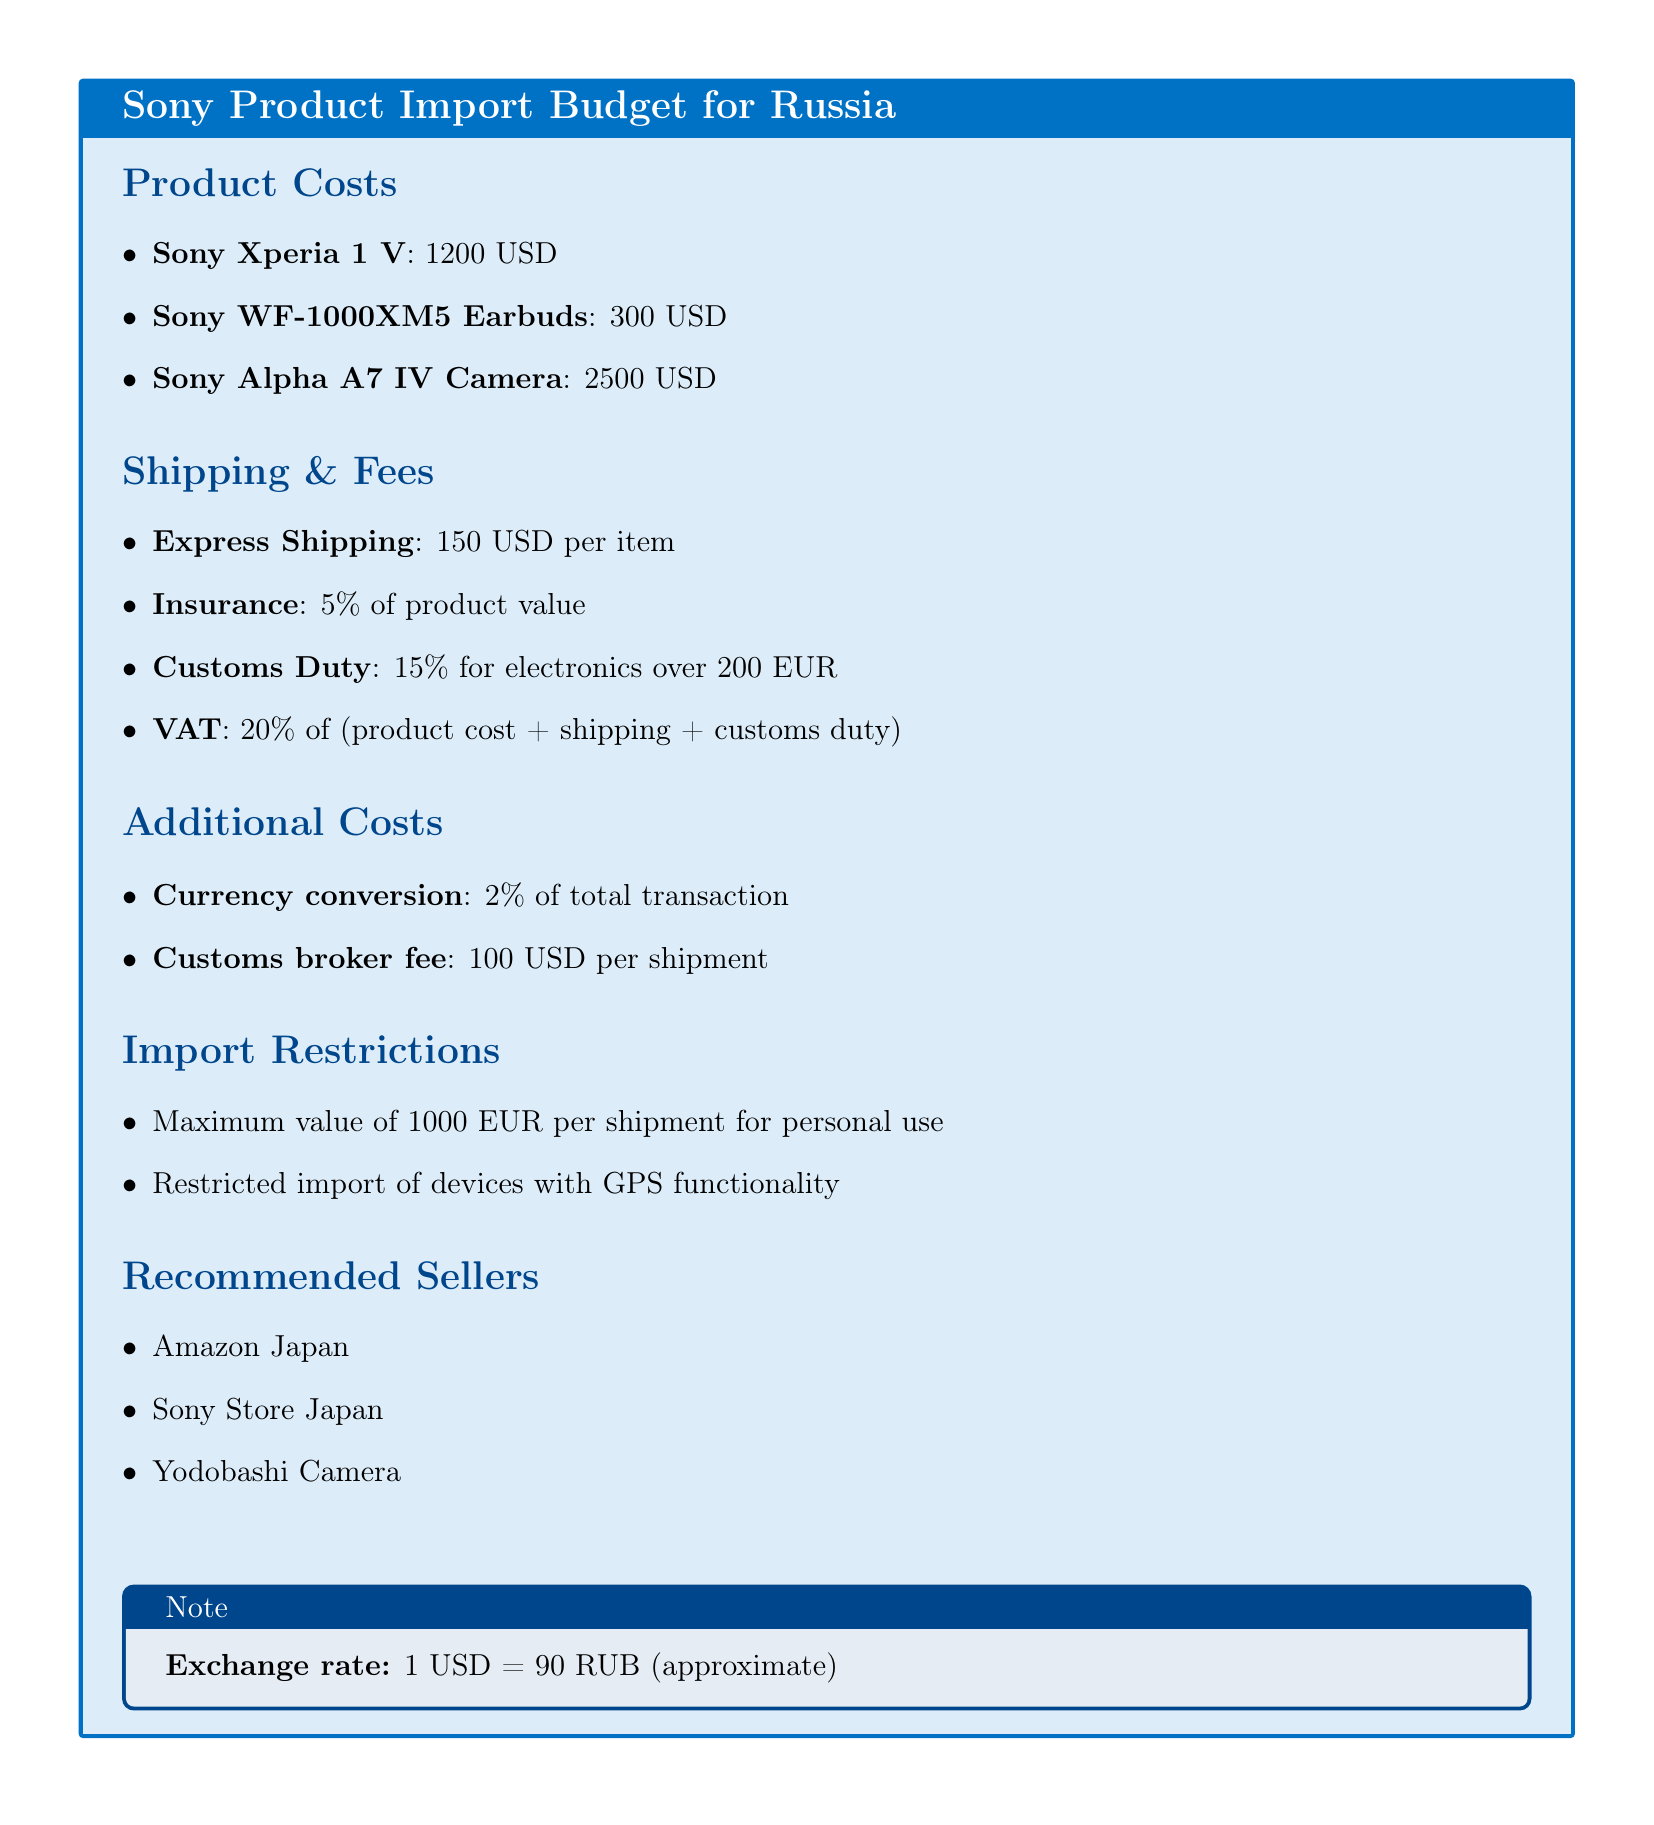What is the cost of Sony Xperia 1 V? The cost of Sony Xperia 1 V is listed in the product costs section of the document.
Answer: 1200 USD What percentage is charged for insurance? The document specifies that insurance is 5% of the product value.
Answer: 5% What is the customs duty percentage for electronics over 200 EUR? The customs duty percentage for electronics over 200 EUR is indicated in the shipping & fees section of the document.
Answer: 15% What is the customs broker fee? The document states the customs broker fee in the additional costs section.
Answer: 100 USD What is the maximum value per shipment for personal use? This limitation is detailed in the import restrictions section of the document.
Answer: 1000 EUR How much is VAT on the total cost? The VAT is calculated as 20% of the product cost plus shipping and customs duty, as outlined in the document.
Answer: 20% Which stores are recommended for purchasing Sony products? The recommended sellers are listed in the recommended sellers section of the document.
Answer: Amazon Japan, Sony Store Japan, Yodobashi Camera What is the exchange rate of USD to RUB? The exchange rate is provided in the note section of the document.
Answer: 1 USD = 90 RUB What is the shipping cost per item? The shipping cost is mentioned in the shipping & fees section of the document.
Answer: 150 USD per item 